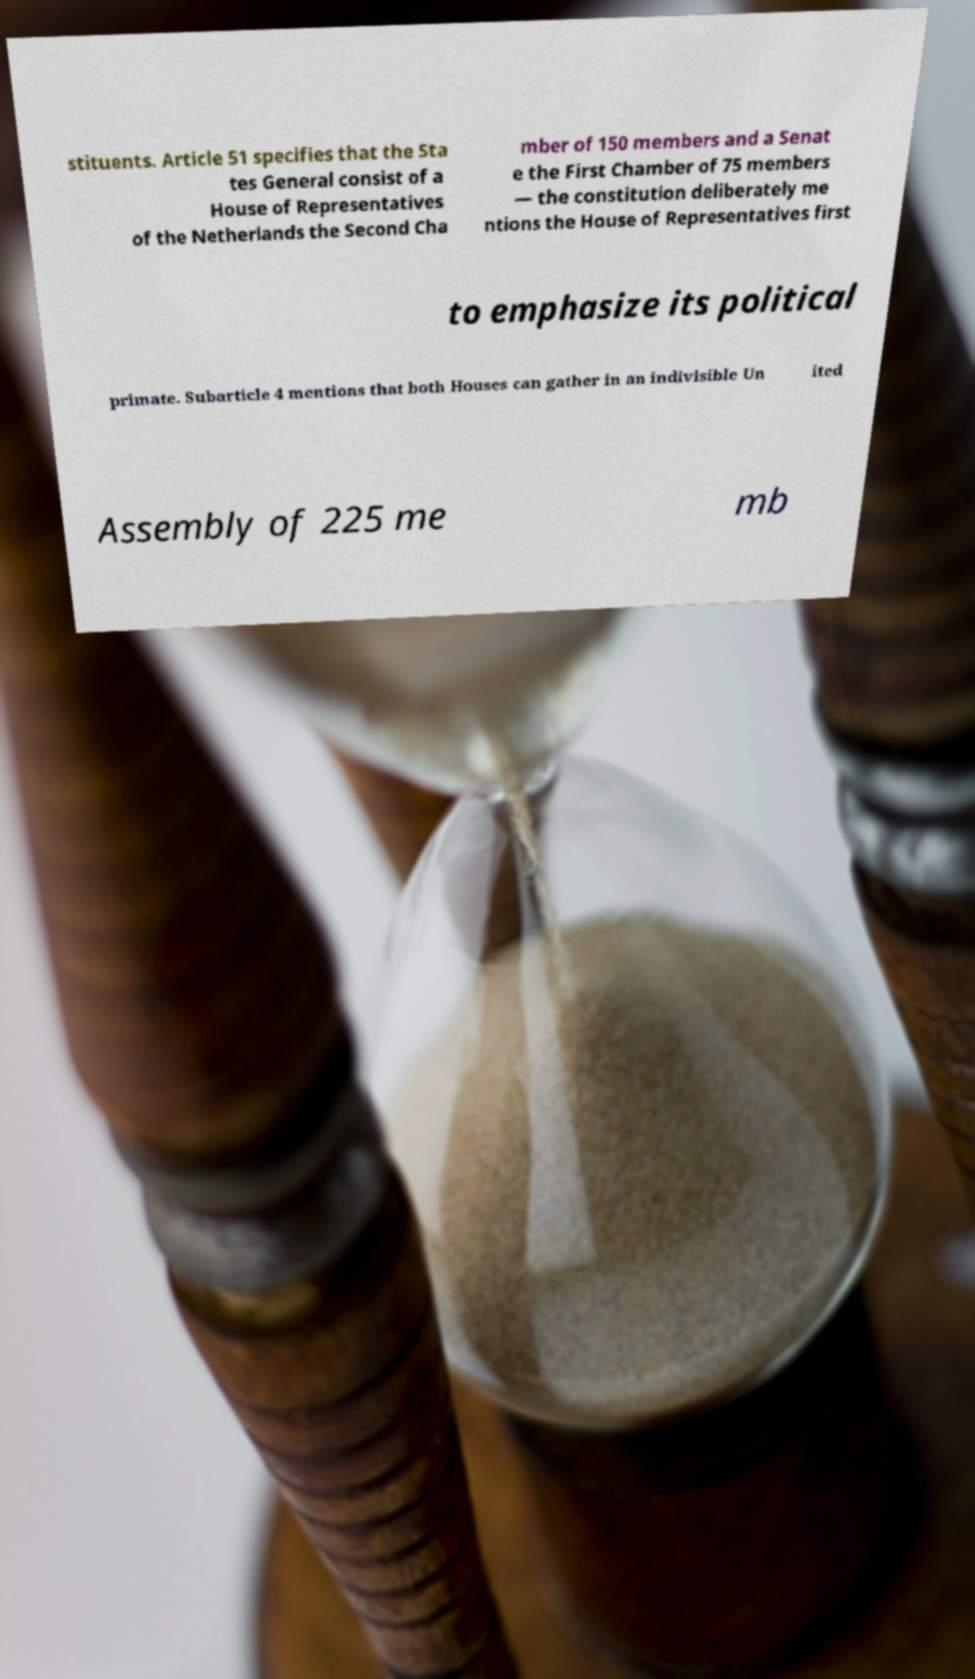I need the written content from this picture converted into text. Can you do that? stituents. Article 51 specifies that the Sta tes General consist of a House of Representatives of the Netherlands the Second Cha mber of 150 members and a Senat e the First Chamber of 75 members — the constitution deliberately me ntions the House of Representatives first to emphasize its political primate. Subarticle 4 mentions that both Houses can gather in an indivisible Un ited Assembly of 225 me mb 